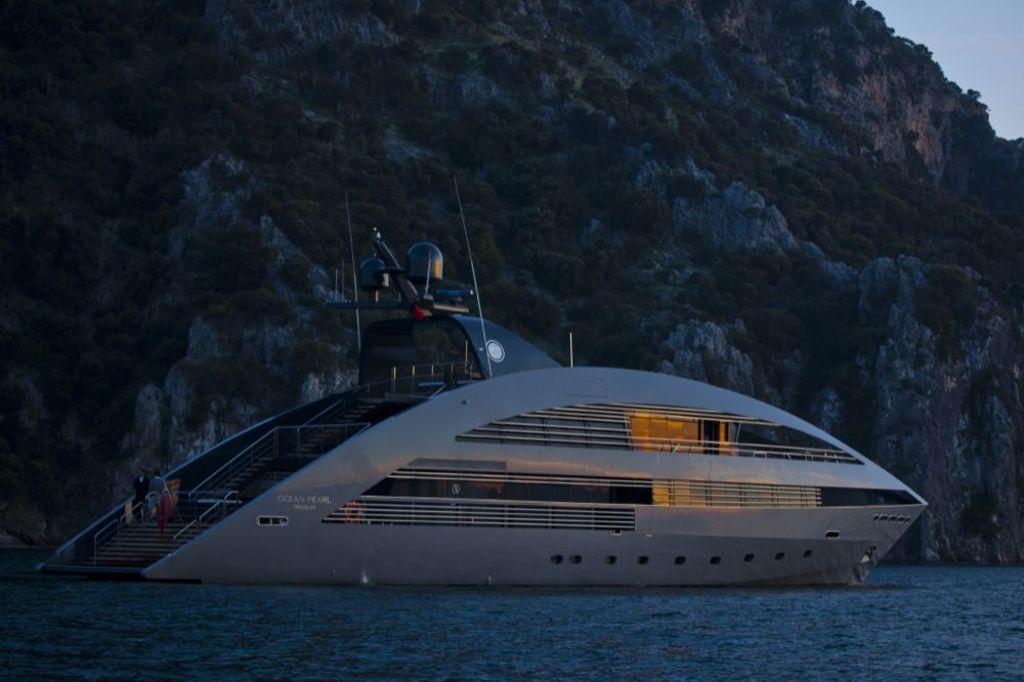Please provide a concise description of this image. In this picture there is a ship on the water. At the back there are trees on the hill. At the top there is sky. At the bottom there is water. 